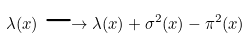Convert formula to latex. <formula><loc_0><loc_0><loc_500><loc_500>\lambda ( x ) \longrightarrow \lambda ( x ) + \sigma ^ { 2 } ( x ) - \pi ^ { 2 } ( x )</formula> 